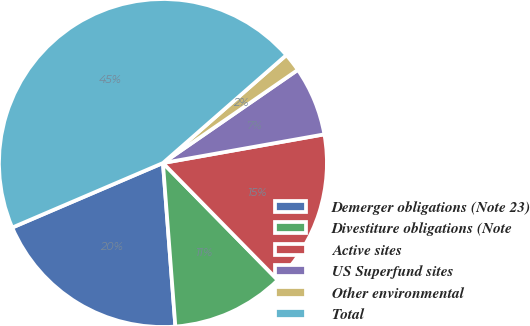Convert chart. <chart><loc_0><loc_0><loc_500><loc_500><pie_chart><fcel>Demerger obligations (Note 23)<fcel>Divestiture obligations (Note<fcel>Active sites<fcel>US Superfund sites<fcel>Other environmental<fcel>Total<nl><fcel>19.77%<fcel>11.14%<fcel>15.45%<fcel>6.82%<fcel>1.82%<fcel>45.0%<nl></chart> 